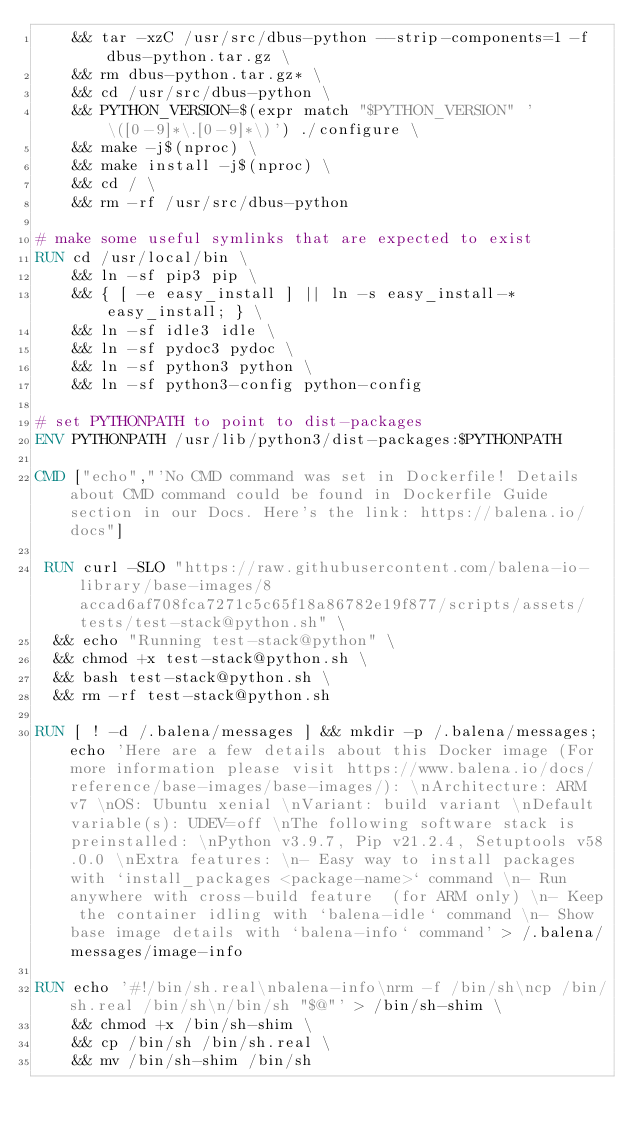<code> <loc_0><loc_0><loc_500><loc_500><_Dockerfile_>	&& tar -xzC /usr/src/dbus-python --strip-components=1 -f dbus-python.tar.gz \
	&& rm dbus-python.tar.gz* \
	&& cd /usr/src/dbus-python \
	&& PYTHON_VERSION=$(expr match "$PYTHON_VERSION" '\([0-9]*\.[0-9]*\)') ./configure \
	&& make -j$(nproc) \
	&& make install -j$(nproc) \
	&& cd / \
	&& rm -rf /usr/src/dbus-python

# make some useful symlinks that are expected to exist
RUN cd /usr/local/bin \
	&& ln -sf pip3 pip \
	&& { [ -e easy_install ] || ln -s easy_install-* easy_install; } \
	&& ln -sf idle3 idle \
	&& ln -sf pydoc3 pydoc \
	&& ln -sf python3 python \
	&& ln -sf python3-config python-config

# set PYTHONPATH to point to dist-packages
ENV PYTHONPATH /usr/lib/python3/dist-packages:$PYTHONPATH

CMD ["echo","'No CMD command was set in Dockerfile! Details about CMD command could be found in Dockerfile Guide section in our Docs. Here's the link: https://balena.io/docs"]

 RUN curl -SLO "https://raw.githubusercontent.com/balena-io-library/base-images/8accad6af708fca7271c5c65f18a86782e19f877/scripts/assets/tests/test-stack@python.sh" \
  && echo "Running test-stack@python" \
  && chmod +x test-stack@python.sh \
  && bash test-stack@python.sh \
  && rm -rf test-stack@python.sh 

RUN [ ! -d /.balena/messages ] && mkdir -p /.balena/messages; echo 'Here are a few details about this Docker image (For more information please visit https://www.balena.io/docs/reference/base-images/base-images/): \nArchitecture: ARM v7 \nOS: Ubuntu xenial \nVariant: build variant \nDefault variable(s): UDEV=off \nThe following software stack is preinstalled: \nPython v3.9.7, Pip v21.2.4, Setuptools v58.0.0 \nExtra features: \n- Easy way to install packages with `install_packages <package-name>` command \n- Run anywhere with cross-build feature  (for ARM only) \n- Keep the container idling with `balena-idle` command \n- Show base image details with `balena-info` command' > /.balena/messages/image-info

RUN echo '#!/bin/sh.real\nbalena-info\nrm -f /bin/sh\ncp /bin/sh.real /bin/sh\n/bin/sh "$@"' > /bin/sh-shim \
	&& chmod +x /bin/sh-shim \
	&& cp /bin/sh /bin/sh.real \
	&& mv /bin/sh-shim /bin/sh</code> 